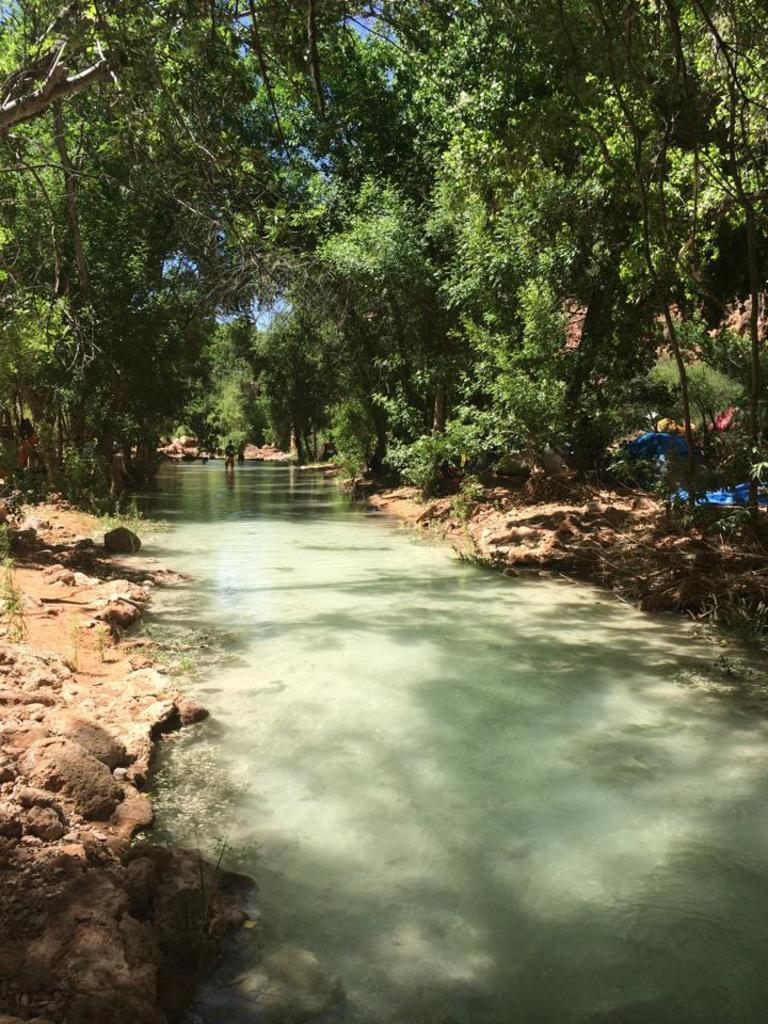What is the person in the image doing? There is a person in the water in the image. What can be seen in the background of the image? There are trees in the image. What type of shelter is present in the image? There are tents in the image. What type of ground surface is visible in the image? There are stones in the image. What is visible above the trees and tents in the image? The sky is visible in the image. What type of arch can be seen in the image? There is no arch present in the image. 